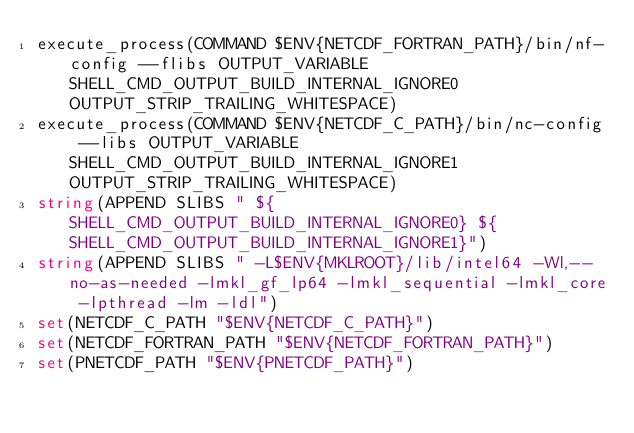Convert code to text. <code><loc_0><loc_0><loc_500><loc_500><_CMake_>execute_process(COMMAND $ENV{NETCDF_FORTRAN_PATH}/bin/nf-config --flibs OUTPUT_VARIABLE SHELL_CMD_OUTPUT_BUILD_INTERNAL_IGNORE0 OUTPUT_STRIP_TRAILING_WHITESPACE)
execute_process(COMMAND $ENV{NETCDF_C_PATH}/bin/nc-config --libs OUTPUT_VARIABLE SHELL_CMD_OUTPUT_BUILD_INTERNAL_IGNORE1 OUTPUT_STRIP_TRAILING_WHITESPACE)
string(APPEND SLIBS " ${SHELL_CMD_OUTPUT_BUILD_INTERNAL_IGNORE0} ${SHELL_CMD_OUTPUT_BUILD_INTERNAL_IGNORE1}")
string(APPEND SLIBS " -L$ENV{MKLROOT}/lib/intel64 -Wl,--no-as-needed -lmkl_gf_lp64 -lmkl_sequential -lmkl_core -lpthread -lm -ldl")
set(NETCDF_C_PATH "$ENV{NETCDF_C_PATH}")
set(NETCDF_FORTRAN_PATH "$ENV{NETCDF_FORTRAN_PATH}")
set(PNETCDF_PATH "$ENV{PNETCDF_PATH}")
</code> 